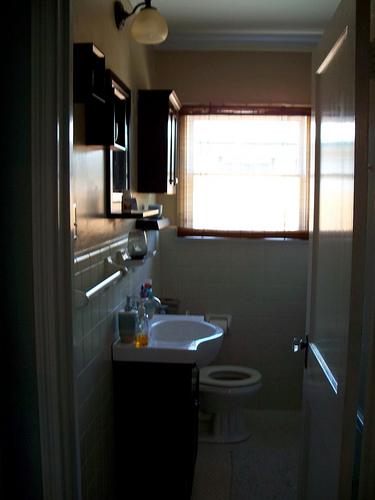Is the light on?
Answer briefly. No. Are there windows in the picture?
Keep it brief. Yes. Is there a tub in the picture?
Be succinct. No. Are the lights on?
Be succinct. No. Does the toilet have a lid?
Answer briefly. Yes. 